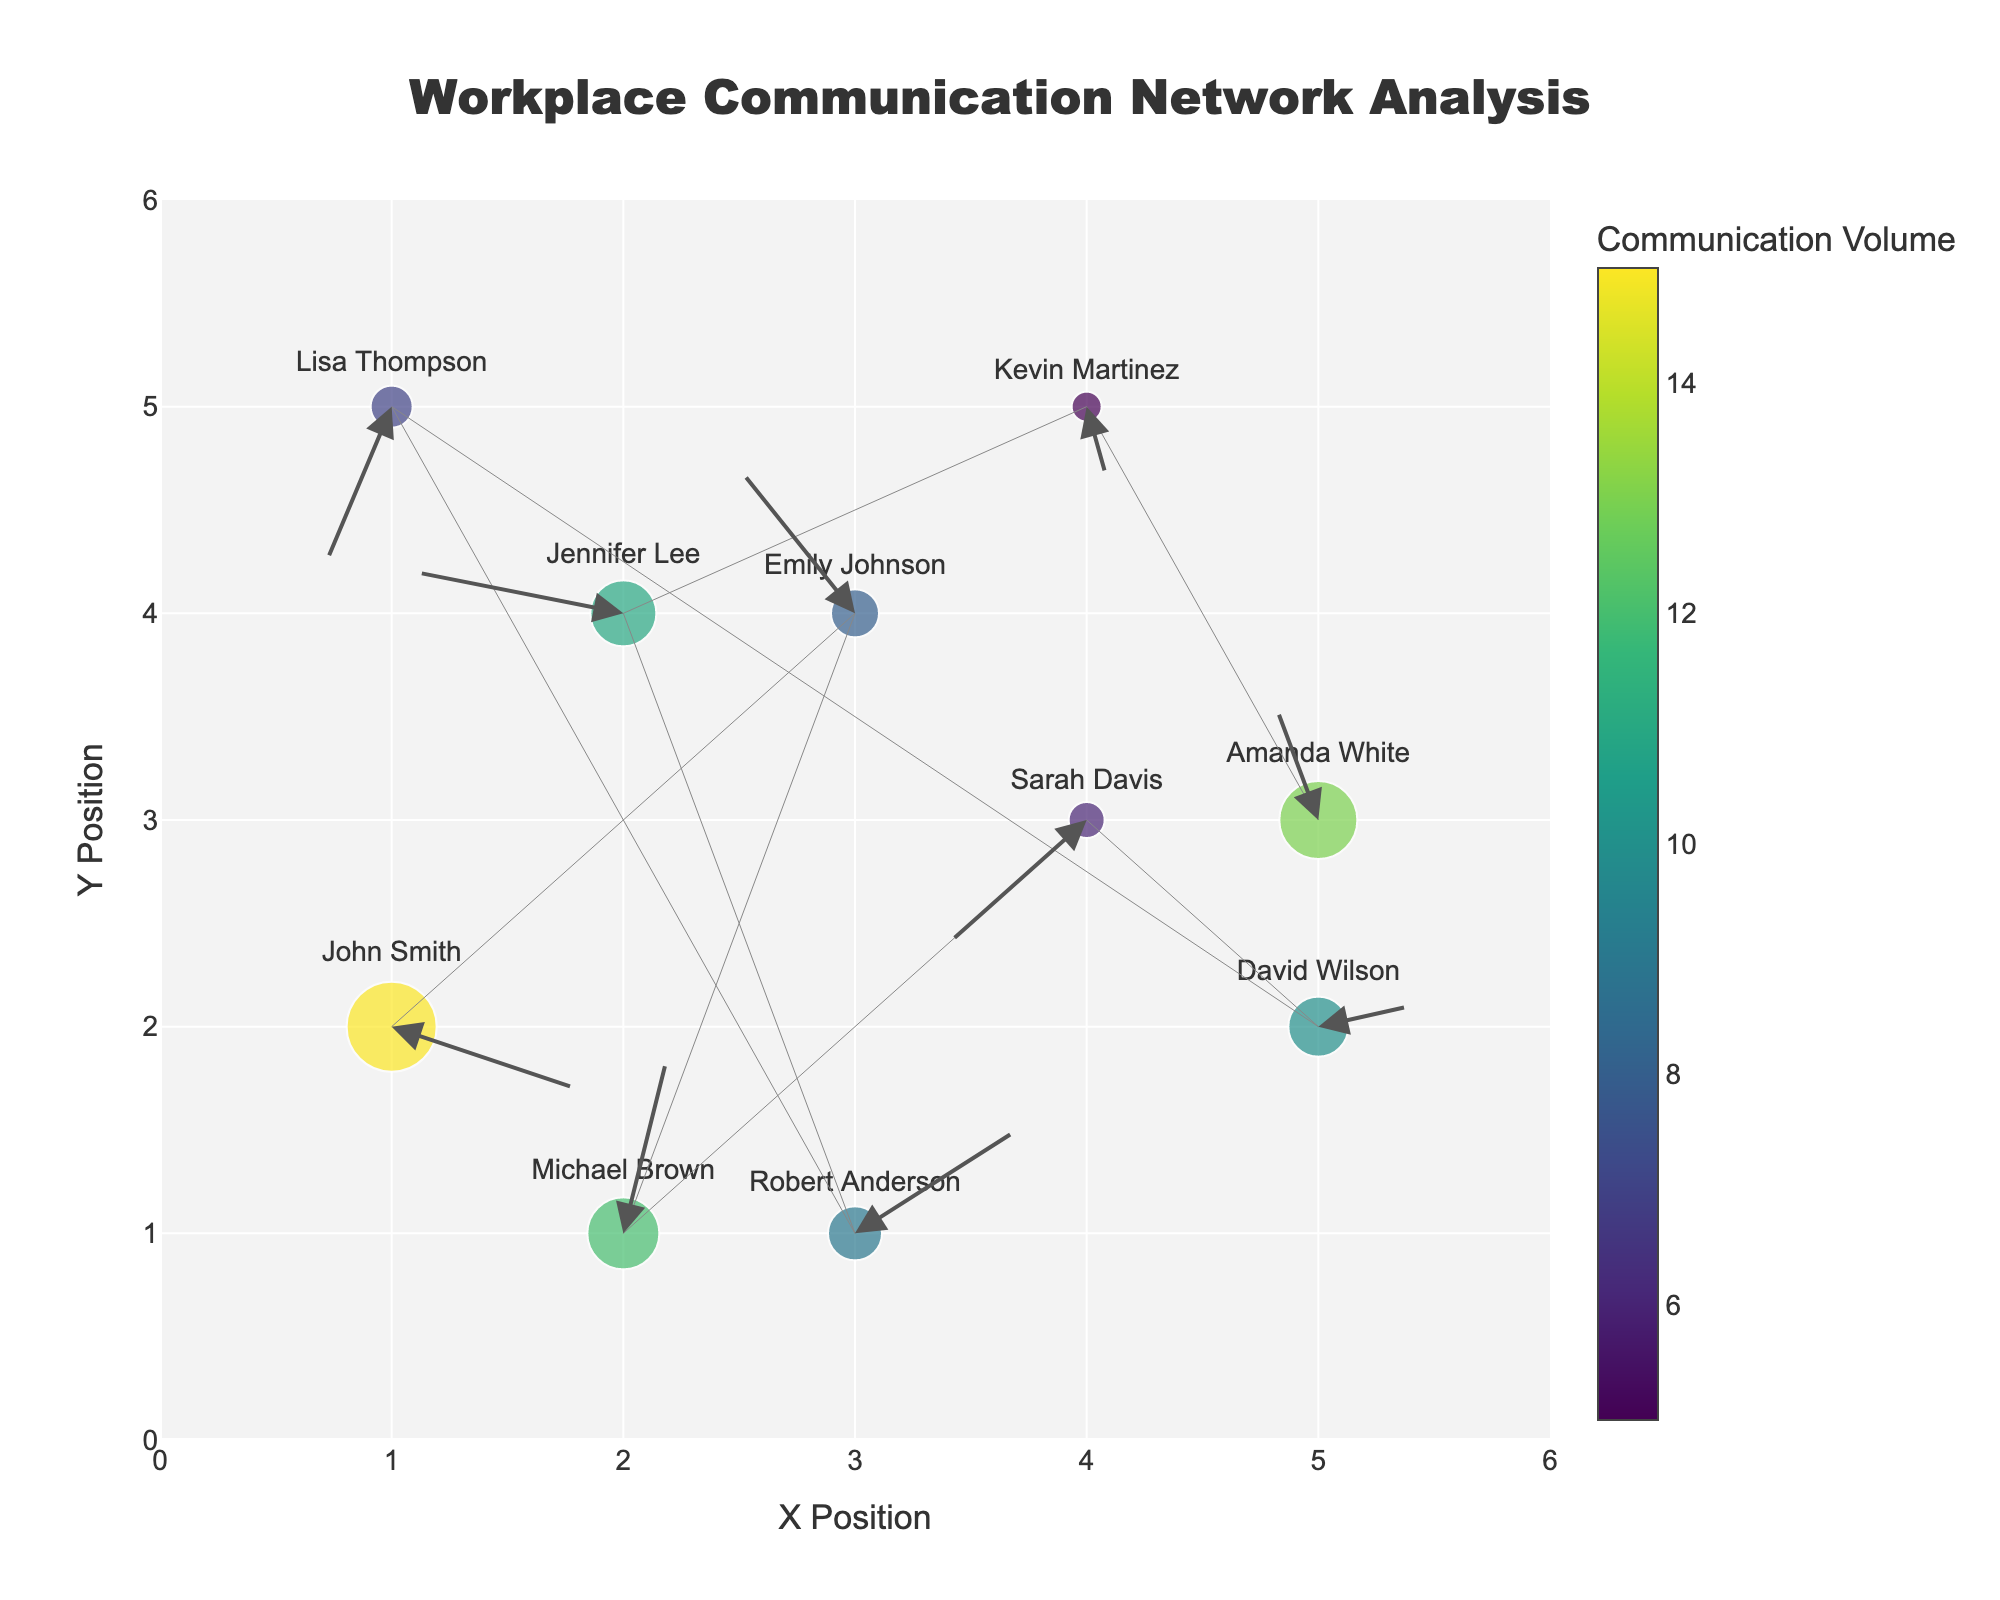What is the title of the figure? Look at the top of the figure where the title is usually placed. The title given is "Workplace Communication Network Analysis".
Answer: Workplace Communication Network Analysis How many employees are represented in the plot? Count the number of unique names listed next to the markers on the plot. There are 10 different names.
Answer: 10 Which employee has the highest communication volume? Look at the size of the markers and the color scale; the largest marker represents the highest communication volume. John Smith has the largest marker.
Answer: John Smith What are the x and y positions of Emily Johnson? Check the figure for Emily Johnson's marker, her position is marked next to her name. Her coordinates are (3, 4).
Answer: (3, 4) Who has the most positive x-direction in their communications? Check the direction of the arrows from each marker; the longest arrow in the positive x-direction belongs to Robert Anderson.
Answer: Robert Anderson Which employees have negative y-direction communications? Look at the direction of the arrows for any arrows pointing downward. Lisa Thompson and Kevin Martinez show negative y-direction communications.
Answer: Lisa Thompson, Kevin Martinez What is the average communication volume among all employees? Sum the communication volumes of all employees and divide by the number of employees: (15 + 8 + 12 + 6 + 10 + 7 + 9 + 11 + 5 + 13) / 10 = 96 / 10 = 9.6.
Answer: 9.6 How many employees have communication volumes greater than 10? Look at the color scale and marker sizes to count the markers representing volumes above 10. There are 4: John Smith, Michael Brown, Jennifer Lee, and Amanda White.
Answer: 4 Which employee has the lowest communication volume? Identify the smallest marker based on size and color; Kevin Martinez has the smallest marker representing the lowest volume.
Answer: Kevin Martinez Who is located at coordinates (4, 3)? Check the plot for the label at position (4, 3). Sarah Davis is located at these coordinates.
Answer: Sarah Davis 